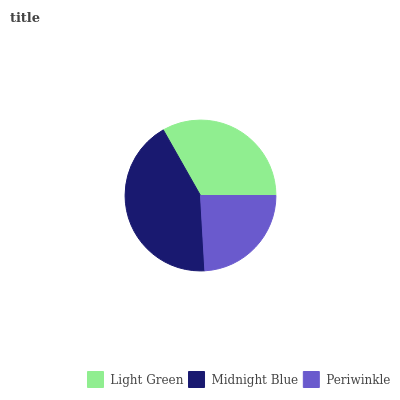Is Periwinkle the minimum?
Answer yes or no. Yes. Is Midnight Blue the maximum?
Answer yes or no. Yes. Is Midnight Blue the minimum?
Answer yes or no. No. Is Periwinkle the maximum?
Answer yes or no. No. Is Midnight Blue greater than Periwinkle?
Answer yes or no. Yes. Is Periwinkle less than Midnight Blue?
Answer yes or no. Yes. Is Periwinkle greater than Midnight Blue?
Answer yes or no. No. Is Midnight Blue less than Periwinkle?
Answer yes or no. No. Is Light Green the high median?
Answer yes or no. Yes. Is Light Green the low median?
Answer yes or no. Yes. Is Periwinkle the high median?
Answer yes or no. No. Is Periwinkle the low median?
Answer yes or no. No. 